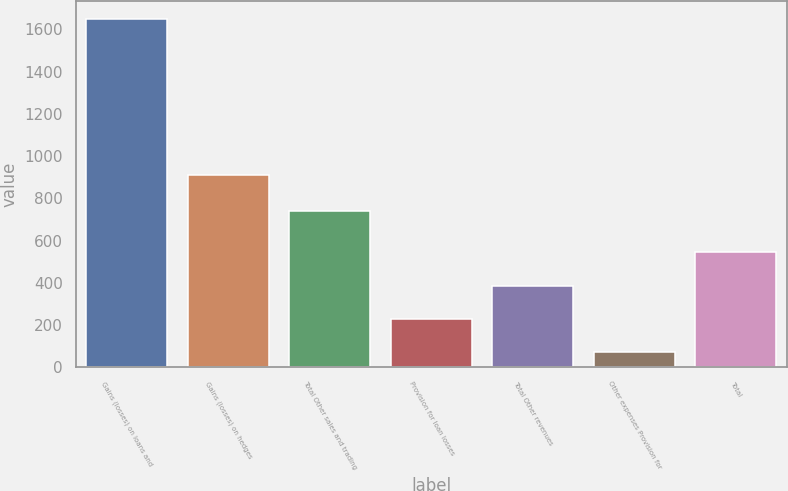<chart> <loc_0><loc_0><loc_500><loc_500><bar_chart><fcel>Gains (losses) on loans and<fcel>Gains (losses) on hedges<fcel>Total Other sales and trading<fcel>Provision for loan losses<fcel>Total Other revenues<fcel>Other expenses Provision for<fcel>Total<nl><fcel>1650<fcel>910<fcel>740<fcel>228.9<fcel>386.8<fcel>71<fcel>544.7<nl></chart> 